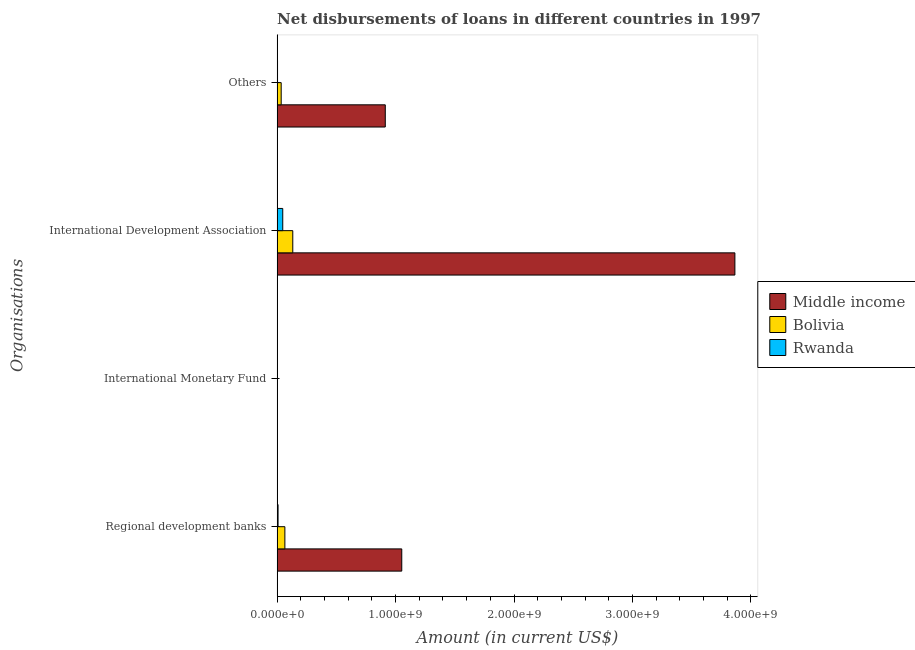Are the number of bars on each tick of the Y-axis equal?
Keep it short and to the point. No. How many bars are there on the 1st tick from the top?
Your answer should be compact. 3. How many bars are there on the 4th tick from the bottom?
Your answer should be compact. 3. What is the label of the 2nd group of bars from the top?
Your answer should be very brief. International Development Association. What is the amount of loan disimbursed by other organisations in Bolivia?
Make the answer very short. 3.43e+07. Across all countries, what is the maximum amount of loan disimbursed by regional development banks?
Give a very brief answer. 1.05e+09. Across all countries, what is the minimum amount of loan disimbursed by other organisations?
Make the answer very short. 3.41e+06. What is the total amount of loan disimbursed by other organisations in the graph?
Your answer should be compact. 9.51e+08. What is the difference between the amount of loan disimbursed by other organisations in Bolivia and that in Rwanda?
Your answer should be compact. 3.09e+07. What is the difference between the amount of loan disimbursed by international monetary fund in Rwanda and the amount of loan disimbursed by other organisations in Bolivia?
Offer a very short reply. -3.43e+07. What is the average amount of loan disimbursed by other organisations per country?
Keep it short and to the point. 3.17e+08. What is the difference between the amount of loan disimbursed by other organisations and amount of loan disimbursed by international development association in Bolivia?
Make the answer very short. -9.79e+07. In how many countries, is the amount of loan disimbursed by other organisations greater than 2600000000 US$?
Ensure brevity in your answer.  0. What is the ratio of the amount of loan disimbursed by other organisations in Middle income to that in Bolivia?
Provide a short and direct response. 26.62. What is the difference between the highest and the second highest amount of loan disimbursed by regional development banks?
Your response must be concise. 9.87e+08. What is the difference between the highest and the lowest amount of loan disimbursed by regional development banks?
Offer a terse response. 1.04e+09. Is the sum of the amount of loan disimbursed by regional development banks in Rwanda and Middle income greater than the maximum amount of loan disimbursed by international monetary fund across all countries?
Your response must be concise. Yes. How many bars are there?
Offer a terse response. 9. Are all the bars in the graph horizontal?
Offer a terse response. Yes. What is the difference between two consecutive major ticks on the X-axis?
Provide a short and direct response. 1.00e+09. Are the values on the major ticks of X-axis written in scientific E-notation?
Make the answer very short. Yes. Does the graph contain grids?
Give a very brief answer. No. How are the legend labels stacked?
Ensure brevity in your answer.  Vertical. What is the title of the graph?
Your response must be concise. Net disbursements of loans in different countries in 1997. Does "Somalia" appear as one of the legend labels in the graph?
Your response must be concise. No. What is the label or title of the Y-axis?
Offer a very short reply. Organisations. What is the Amount (in current US$) of Middle income in Regional development banks?
Make the answer very short. 1.05e+09. What is the Amount (in current US$) in Bolivia in Regional development banks?
Your response must be concise. 6.54e+07. What is the Amount (in current US$) in Rwanda in Regional development banks?
Give a very brief answer. 7.89e+06. What is the Amount (in current US$) in Middle income in International Monetary Fund?
Your answer should be compact. 0. What is the Amount (in current US$) of Rwanda in International Monetary Fund?
Offer a very short reply. 0. What is the Amount (in current US$) of Middle income in International Development Association?
Give a very brief answer. 3.86e+09. What is the Amount (in current US$) in Bolivia in International Development Association?
Provide a short and direct response. 1.32e+08. What is the Amount (in current US$) in Rwanda in International Development Association?
Ensure brevity in your answer.  4.75e+07. What is the Amount (in current US$) in Middle income in Others?
Provide a short and direct response. 9.13e+08. What is the Amount (in current US$) of Bolivia in Others?
Ensure brevity in your answer.  3.43e+07. What is the Amount (in current US$) of Rwanda in Others?
Keep it short and to the point. 3.41e+06. Across all Organisations, what is the maximum Amount (in current US$) of Middle income?
Make the answer very short. 3.86e+09. Across all Organisations, what is the maximum Amount (in current US$) of Bolivia?
Make the answer very short. 1.32e+08. Across all Organisations, what is the maximum Amount (in current US$) of Rwanda?
Make the answer very short. 4.75e+07. Across all Organisations, what is the minimum Amount (in current US$) of Rwanda?
Give a very brief answer. 0. What is the total Amount (in current US$) in Middle income in the graph?
Make the answer very short. 5.83e+09. What is the total Amount (in current US$) of Bolivia in the graph?
Keep it short and to the point. 2.32e+08. What is the total Amount (in current US$) of Rwanda in the graph?
Make the answer very short. 5.88e+07. What is the difference between the Amount (in current US$) in Middle income in Regional development banks and that in International Development Association?
Keep it short and to the point. -2.81e+09. What is the difference between the Amount (in current US$) in Bolivia in Regional development banks and that in International Development Association?
Keep it short and to the point. -6.68e+07. What is the difference between the Amount (in current US$) of Rwanda in Regional development banks and that in International Development Association?
Offer a very short reply. -3.96e+07. What is the difference between the Amount (in current US$) in Middle income in Regional development banks and that in Others?
Offer a terse response. 1.39e+08. What is the difference between the Amount (in current US$) of Bolivia in Regional development banks and that in Others?
Your answer should be compact. 3.11e+07. What is the difference between the Amount (in current US$) in Rwanda in Regional development banks and that in Others?
Your answer should be compact. 4.48e+06. What is the difference between the Amount (in current US$) of Middle income in International Development Association and that in Others?
Ensure brevity in your answer.  2.95e+09. What is the difference between the Amount (in current US$) of Bolivia in International Development Association and that in Others?
Offer a very short reply. 9.79e+07. What is the difference between the Amount (in current US$) in Rwanda in International Development Association and that in Others?
Your answer should be compact. 4.41e+07. What is the difference between the Amount (in current US$) of Middle income in Regional development banks and the Amount (in current US$) of Bolivia in International Development Association?
Provide a short and direct response. 9.20e+08. What is the difference between the Amount (in current US$) of Middle income in Regional development banks and the Amount (in current US$) of Rwanda in International Development Association?
Keep it short and to the point. 1.00e+09. What is the difference between the Amount (in current US$) of Bolivia in Regional development banks and the Amount (in current US$) of Rwanda in International Development Association?
Make the answer very short. 1.79e+07. What is the difference between the Amount (in current US$) in Middle income in Regional development banks and the Amount (in current US$) in Bolivia in Others?
Your answer should be compact. 1.02e+09. What is the difference between the Amount (in current US$) of Middle income in Regional development banks and the Amount (in current US$) of Rwanda in Others?
Provide a succinct answer. 1.05e+09. What is the difference between the Amount (in current US$) in Bolivia in Regional development banks and the Amount (in current US$) in Rwanda in Others?
Offer a terse response. 6.20e+07. What is the difference between the Amount (in current US$) of Middle income in International Development Association and the Amount (in current US$) of Bolivia in Others?
Offer a very short reply. 3.83e+09. What is the difference between the Amount (in current US$) of Middle income in International Development Association and the Amount (in current US$) of Rwanda in Others?
Keep it short and to the point. 3.86e+09. What is the difference between the Amount (in current US$) of Bolivia in International Development Association and the Amount (in current US$) of Rwanda in Others?
Give a very brief answer. 1.29e+08. What is the average Amount (in current US$) in Middle income per Organisations?
Make the answer very short. 1.46e+09. What is the average Amount (in current US$) in Bolivia per Organisations?
Your answer should be very brief. 5.80e+07. What is the average Amount (in current US$) of Rwanda per Organisations?
Provide a succinct answer. 1.47e+07. What is the difference between the Amount (in current US$) of Middle income and Amount (in current US$) of Bolivia in Regional development banks?
Make the answer very short. 9.87e+08. What is the difference between the Amount (in current US$) of Middle income and Amount (in current US$) of Rwanda in Regional development banks?
Offer a terse response. 1.04e+09. What is the difference between the Amount (in current US$) of Bolivia and Amount (in current US$) of Rwanda in Regional development banks?
Provide a succinct answer. 5.75e+07. What is the difference between the Amount (in current US$) in Middle income and Amount (in current US$) in Bolivia in International Development Association?
Provide a short and direct response. 3.73e+09. What is the difference between the Amount (in current US$) in Middle income and Amount (in current US$) in Rwanda in International Development Association?
Your response must be concise. 3.82e+09. What is the difference between the Amount (in current US$) in Bolivia and Amount (in current US$) in Rwanda in International Development Association?
Ensure brevity in your answer.  8.46e+07. What is the difference between the Amount (in current US$) in Middle income and Amount (in current US$) in Bolivia in Others?
Your response must be concise. 8.79e+08. What is the difference between the Amount (in current US$) of Middle income and Amount (in current US$) of Rwanda in Others?
Provide a succinct answer. 9.10e+08. What is the difference between the Amount (in current US$) of Bolivia and Amount (in current US$) of Rwanda in Others?
Keep it short and to the point. 3.09e+07. What is the ratio of the Amount (in current US$) of Middle income in Regional development banks to that in International Development Association?
Your response must be concise. 0.27. What is the ratio of the Amount (in current US$) in Bolivia in Regional development banks to that in International Development Association?
Your answer should be very brief. 0.49. What is the ratio of the Amount (in current US$) of Rwanda in Regional development banks to that in International Development Association?
Your answer should be very brief. 0.17. What is the ratio of the Amount (in current US$) in Middle income in Regional development banks to that in Others?
Keep it short and to the point. 1.15. What is the ratio of the Amount (in current US$) of Bolivia in Regional development banks to that in Others?
Your answer should be compact. 1.91. What is the ratio of the Amount (in current US$) in Rwanda in Regional development banks to that in Others?
Your response must be concise. 2.32. What is the ratio of the Amount (in current US$) of Middle income in International Development Association to that in Others?
Keep it short and to the point. 4.23. What is the ratio of the Amount (in current US$) of Bolivia in International Development Association to that in Others?
Make the answer very short. 3.85. What is the ratio of the Amount (in current US$) in Rwanda in International Development Association to that in Others?
Offer a terse response. 13.95. What is the difference between the highest and the second highest Amount (in current US$) in Middle income?
Keep it short and to the point. 2.81e+09. What is the difference between the highest and the second highest Amount (in current US$) in Bolivia?
Make the answer very short. 6.68e+07. What is the difference between the highest and the second highest Amount (in current US$) in Rwanda?
Provide a succinct answer. 3.96e+07. What is the difference between the highest and the lowest Amount (in current US$) in Middle income?
Keep it short and to the point. 3.86e+09. What is the difference between the highest and the lowest Amount (in current US$) in Bolivia?
Your response must be concise. 1.32e+08. What is the difference between the highest and the lowest Amount (in current US$) in Rwanda?
Ensure brevity in your answer.  4.75e+07. 